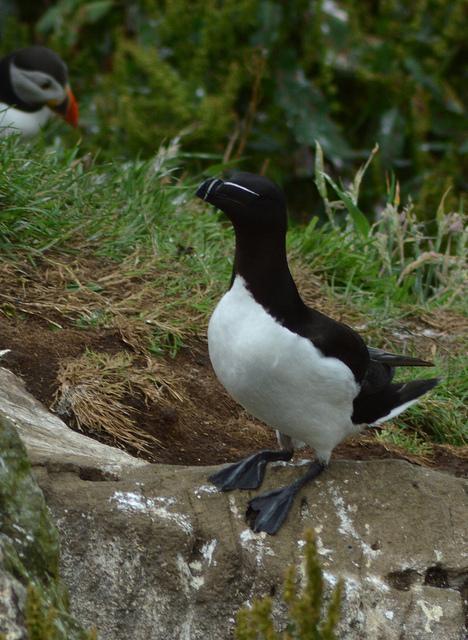How many birds are visible?
Give a very brief answer. 2. How many people are wearing pink?
Give a very brief answer. 0. 